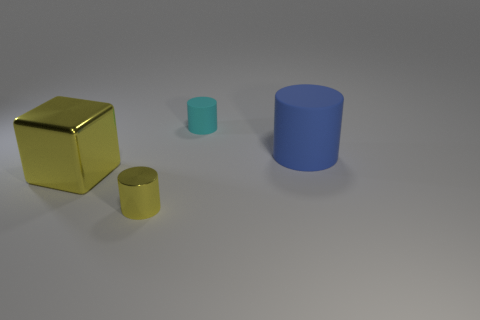Add 4 red metal blocks. How many objects exist? 8 Subtract all cylinders. How many objects are left? 1 Add 2 big blue cylinders. How many big blue cylinders exist? 3 Subtract 0 gray blocks. How many objects are left? 4 Subtract all large shiny cubes. Subtract all green cylinders. How many objects are left? 3 Add 4 yellow shiny objects. How many yellow shiny objects are left? 6 